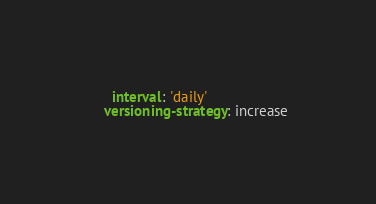<code> <loc_0><loc_0><loc_500><loc_500><_YAML_>      interval: 'daily'
    versioning-strategy: increase</code> 